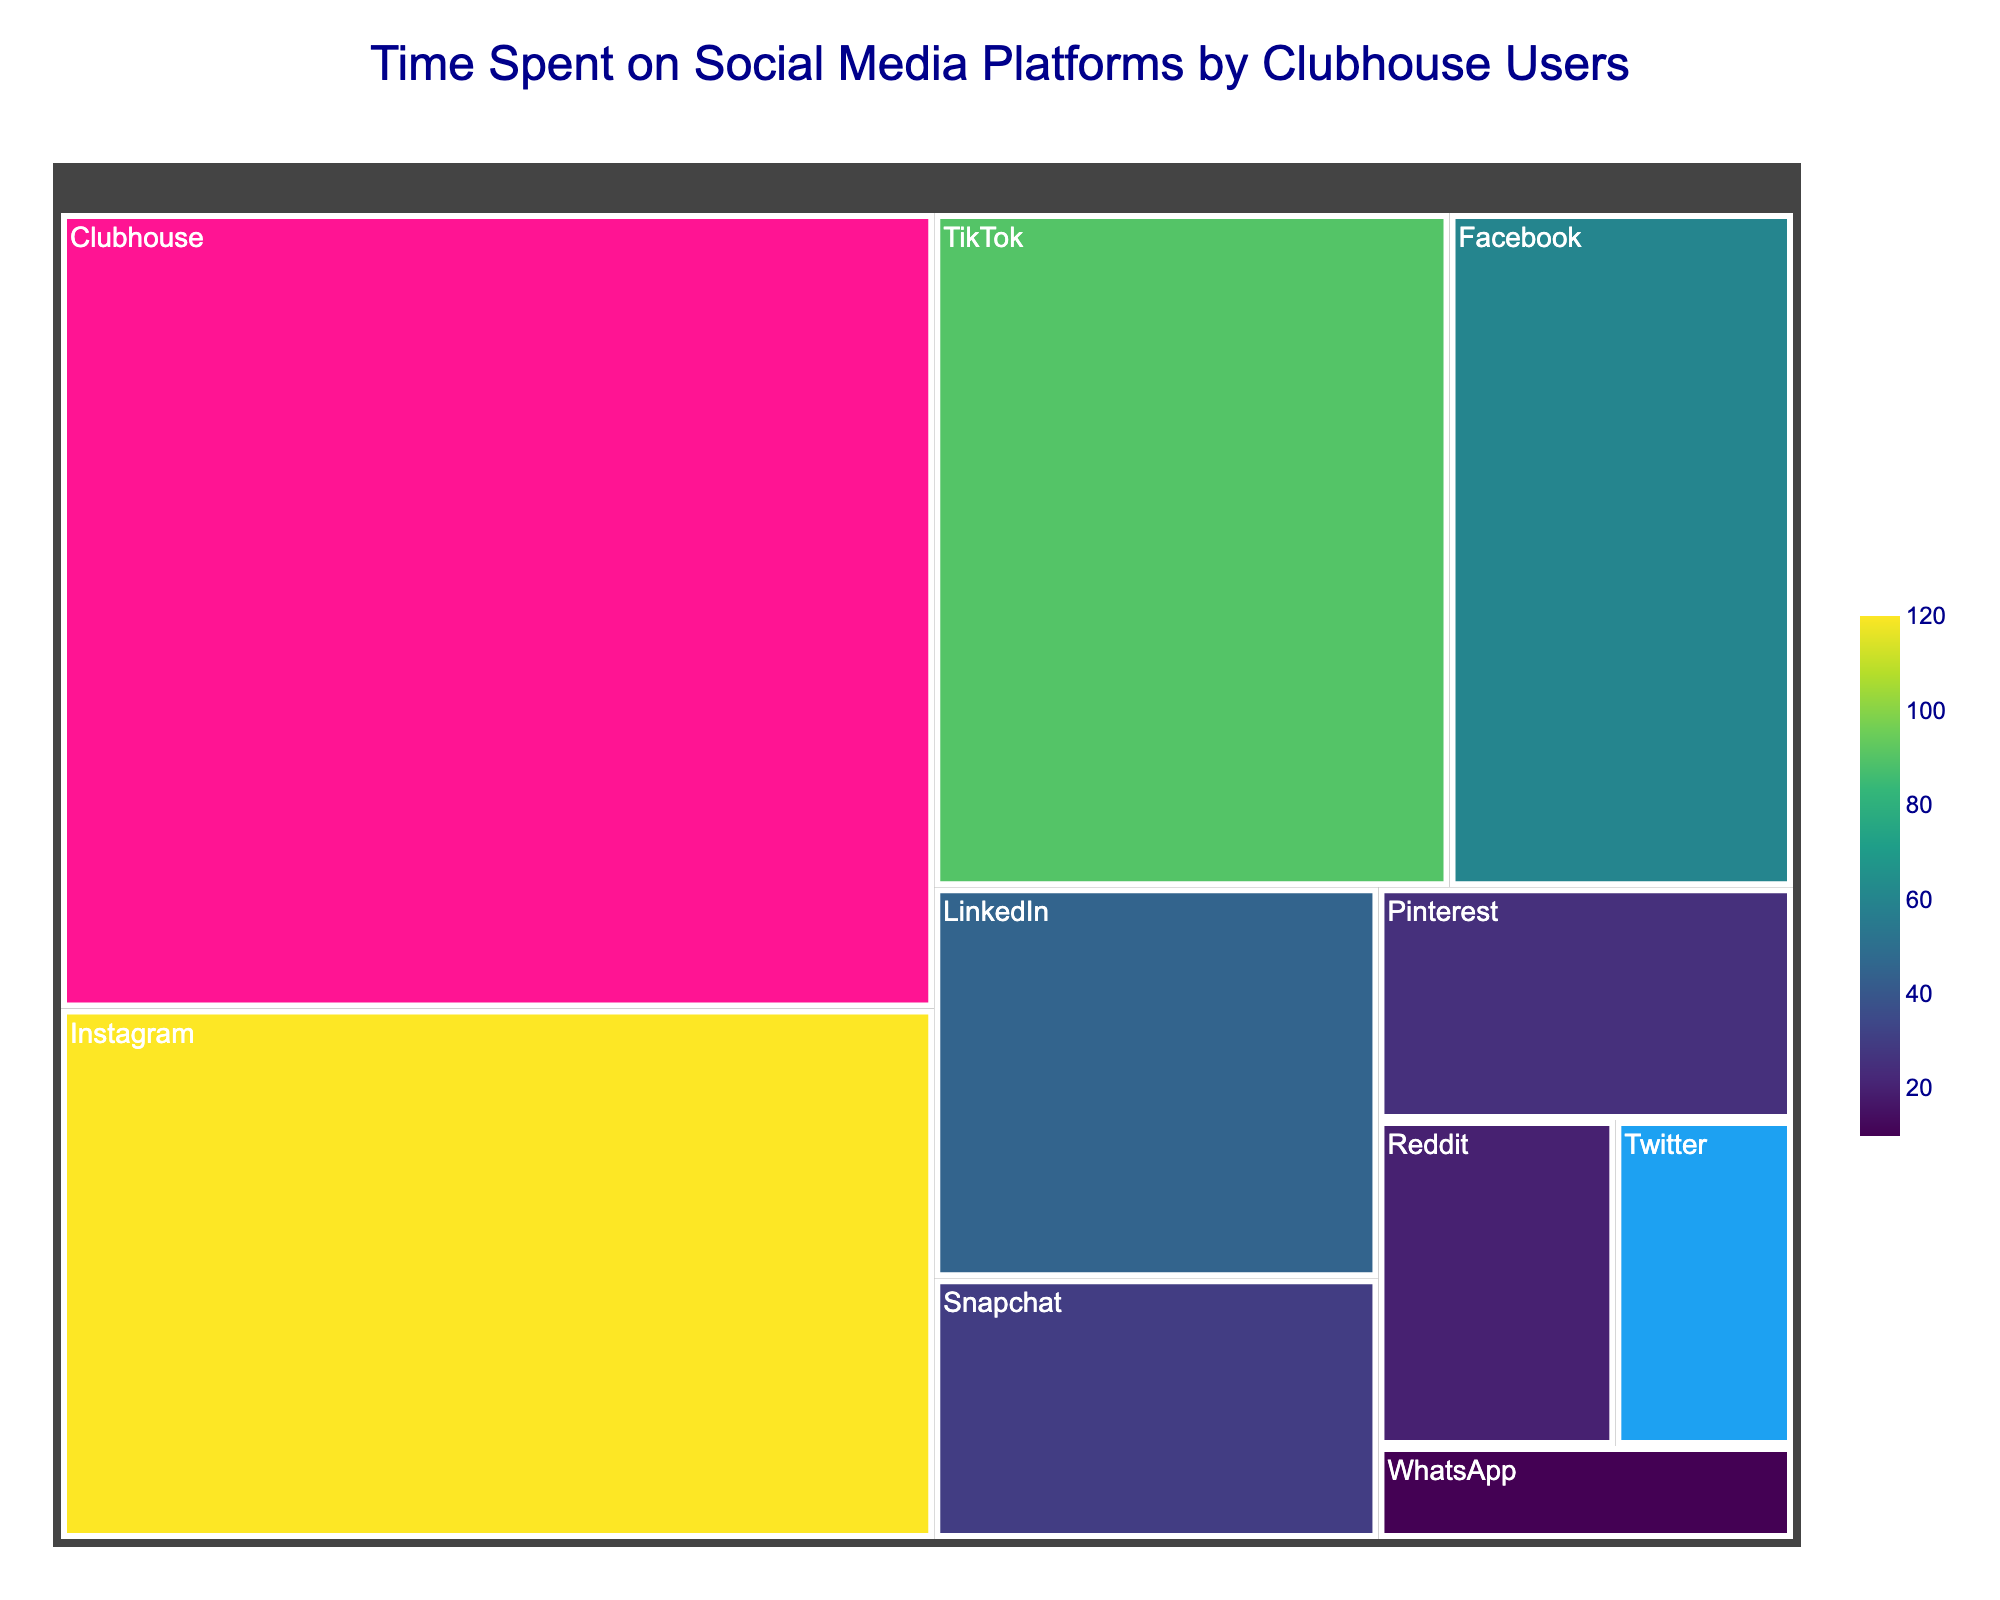What's the platform with the highest time spent? The figure shows the total time spent on each platform. The platform with the largest area and the standout color, deep pink, is Clubhouse with 180 minutes.
Answer: Clubhouse How many minutes are spent on Twitter? The area representing Twitter is the smallest, colored in light blue, and the hover text indicates 15 minutes.
Answer: 15 minutes Which platform do users spend the least time on overall? By examining the smallest area in the treemap, colored in light green, the platform is WhatsApp with 10 minutes.
Answer: WhatsApp What's the combined time spent on Instagram, TikTok, and Facebook? Summing the values for Instagram (120), TikTok (90), and Facebook (60) gives 120 + 90 + 60 = 270 minutes.
Answer: 270 minutes Is more time spent on LinkedIn or Snapchat? Comparing the areas and checking their values, LinkedIn has 45 minutes while Snapchat has 30 minutes.
Answer: LinkedIn How much more time is spent on Clubhouse compared to Instagram? Clubhouse users spend 180 minutes, and Instagram users spend 120 minutes. The difference is 180 - 120 = 60 minutes.
Answer: 60 minutes What is the total time spent on social media platforms? Summing the time for all platforms (180+120+90+60+45+30+25+20+15+10) results in 595 minutes.
Answer: 595 minutes What's the rank of Twitter in terms of time spent? Twitter's time spent can be located as 15 minutes, and sequentially listing platforms by time spent shows Twitter is ninth.
Answer: Ninth What's the average time spent on these platforms? Dividing the total time spent (595 minutes) by the number of platforms (10) results in an average of 595/10 = 59.5 minutes.
Answer: 59.5 minutes Which platforms have less time spent than Pinterest? Platforms with less time than Pinterest (25 minutes) include Reddit, Twitter, and WhatsApp.
Answer: Reddit, Twitter, WhatsApp 